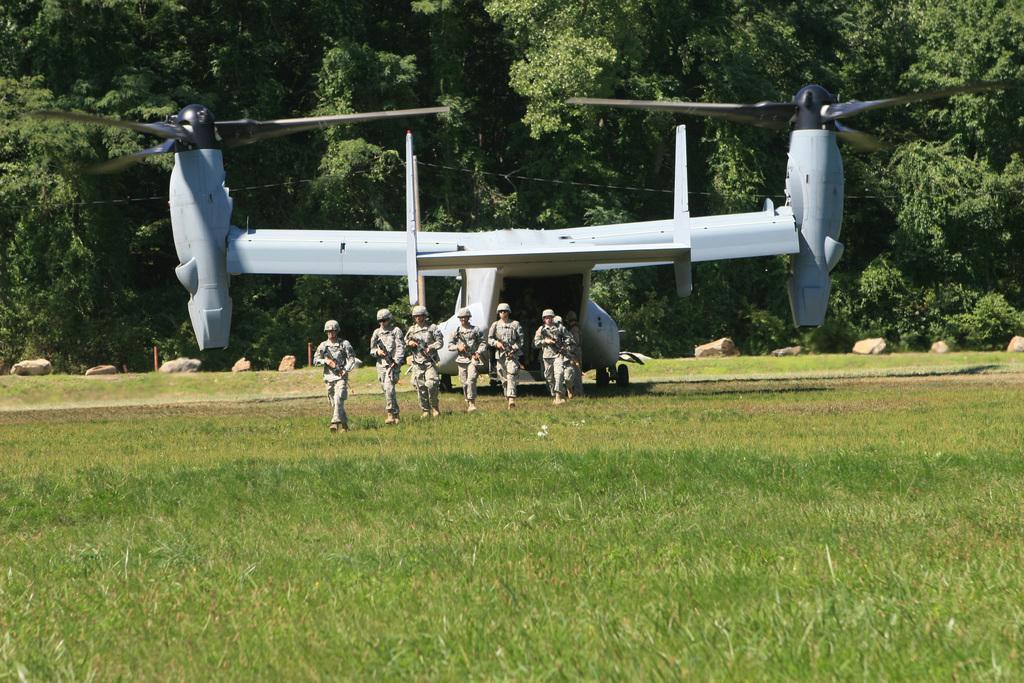In one or two sentences, can you explain what this image depicts? In this picture we can see few people are walking on the grass, and they are holding guns, behind to them we can see a plane and few trees. 